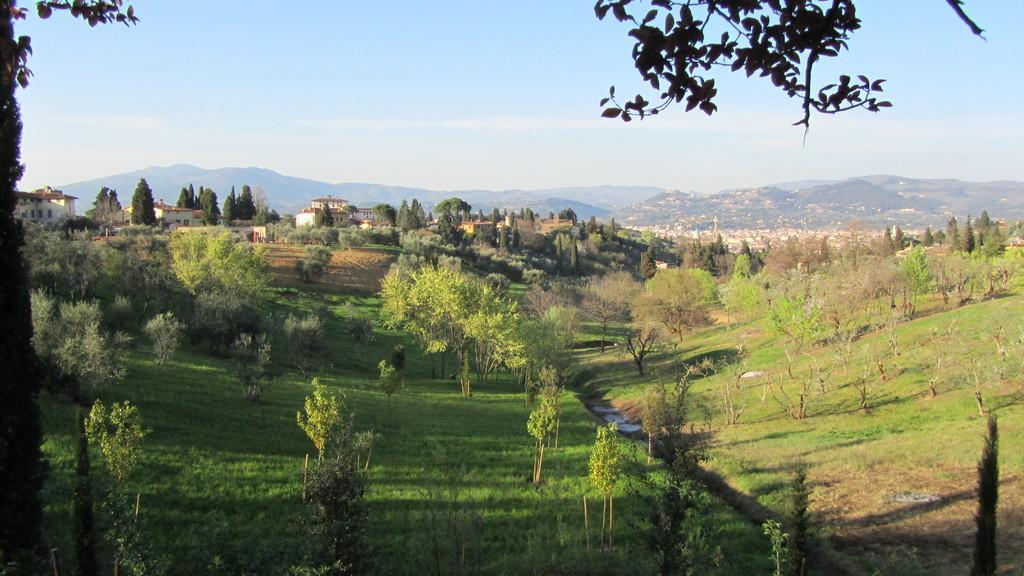Could you give a brief overview of what you see in this image? In this picture we can see grass, trees and a water line passing through here and in the background we can see a beautiful house over the hill surrounded with trees and here it is a mountain and above this there is a sky. 